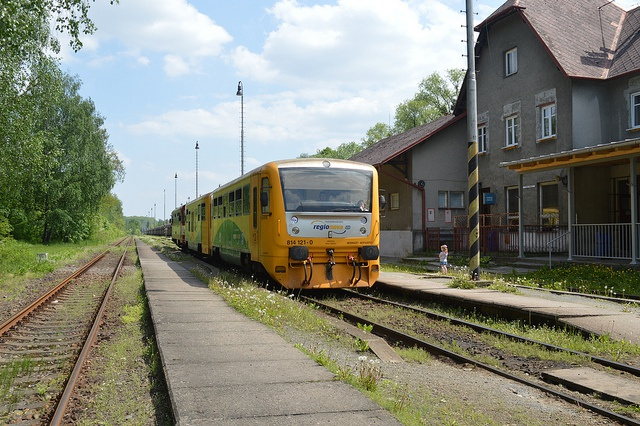Describe the objects in this image and their specific colors. I can see train in darkgreen, olive, black, and darkgray tones, people in darkgreen, gray, darkgray, and black tones, and people in darkgreen, gray, darkgray, and white tones in this image. 